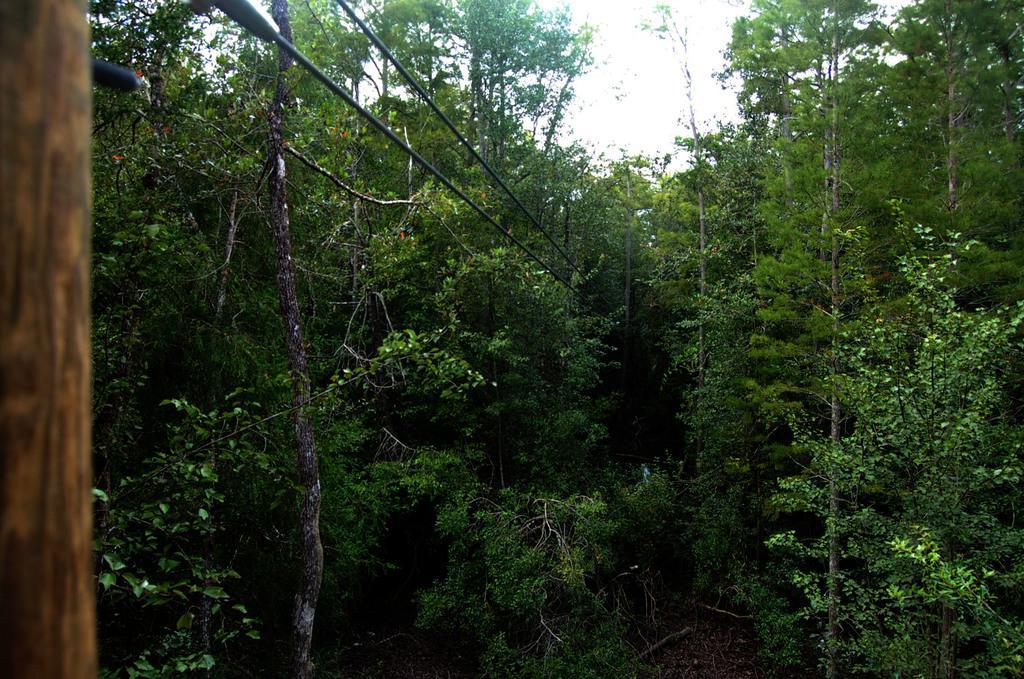Describe this image in one or two sentences. In this picture I can see the ropes on the left side, it looks like a log. In the middle there are trees, at the top I can see the sky. 